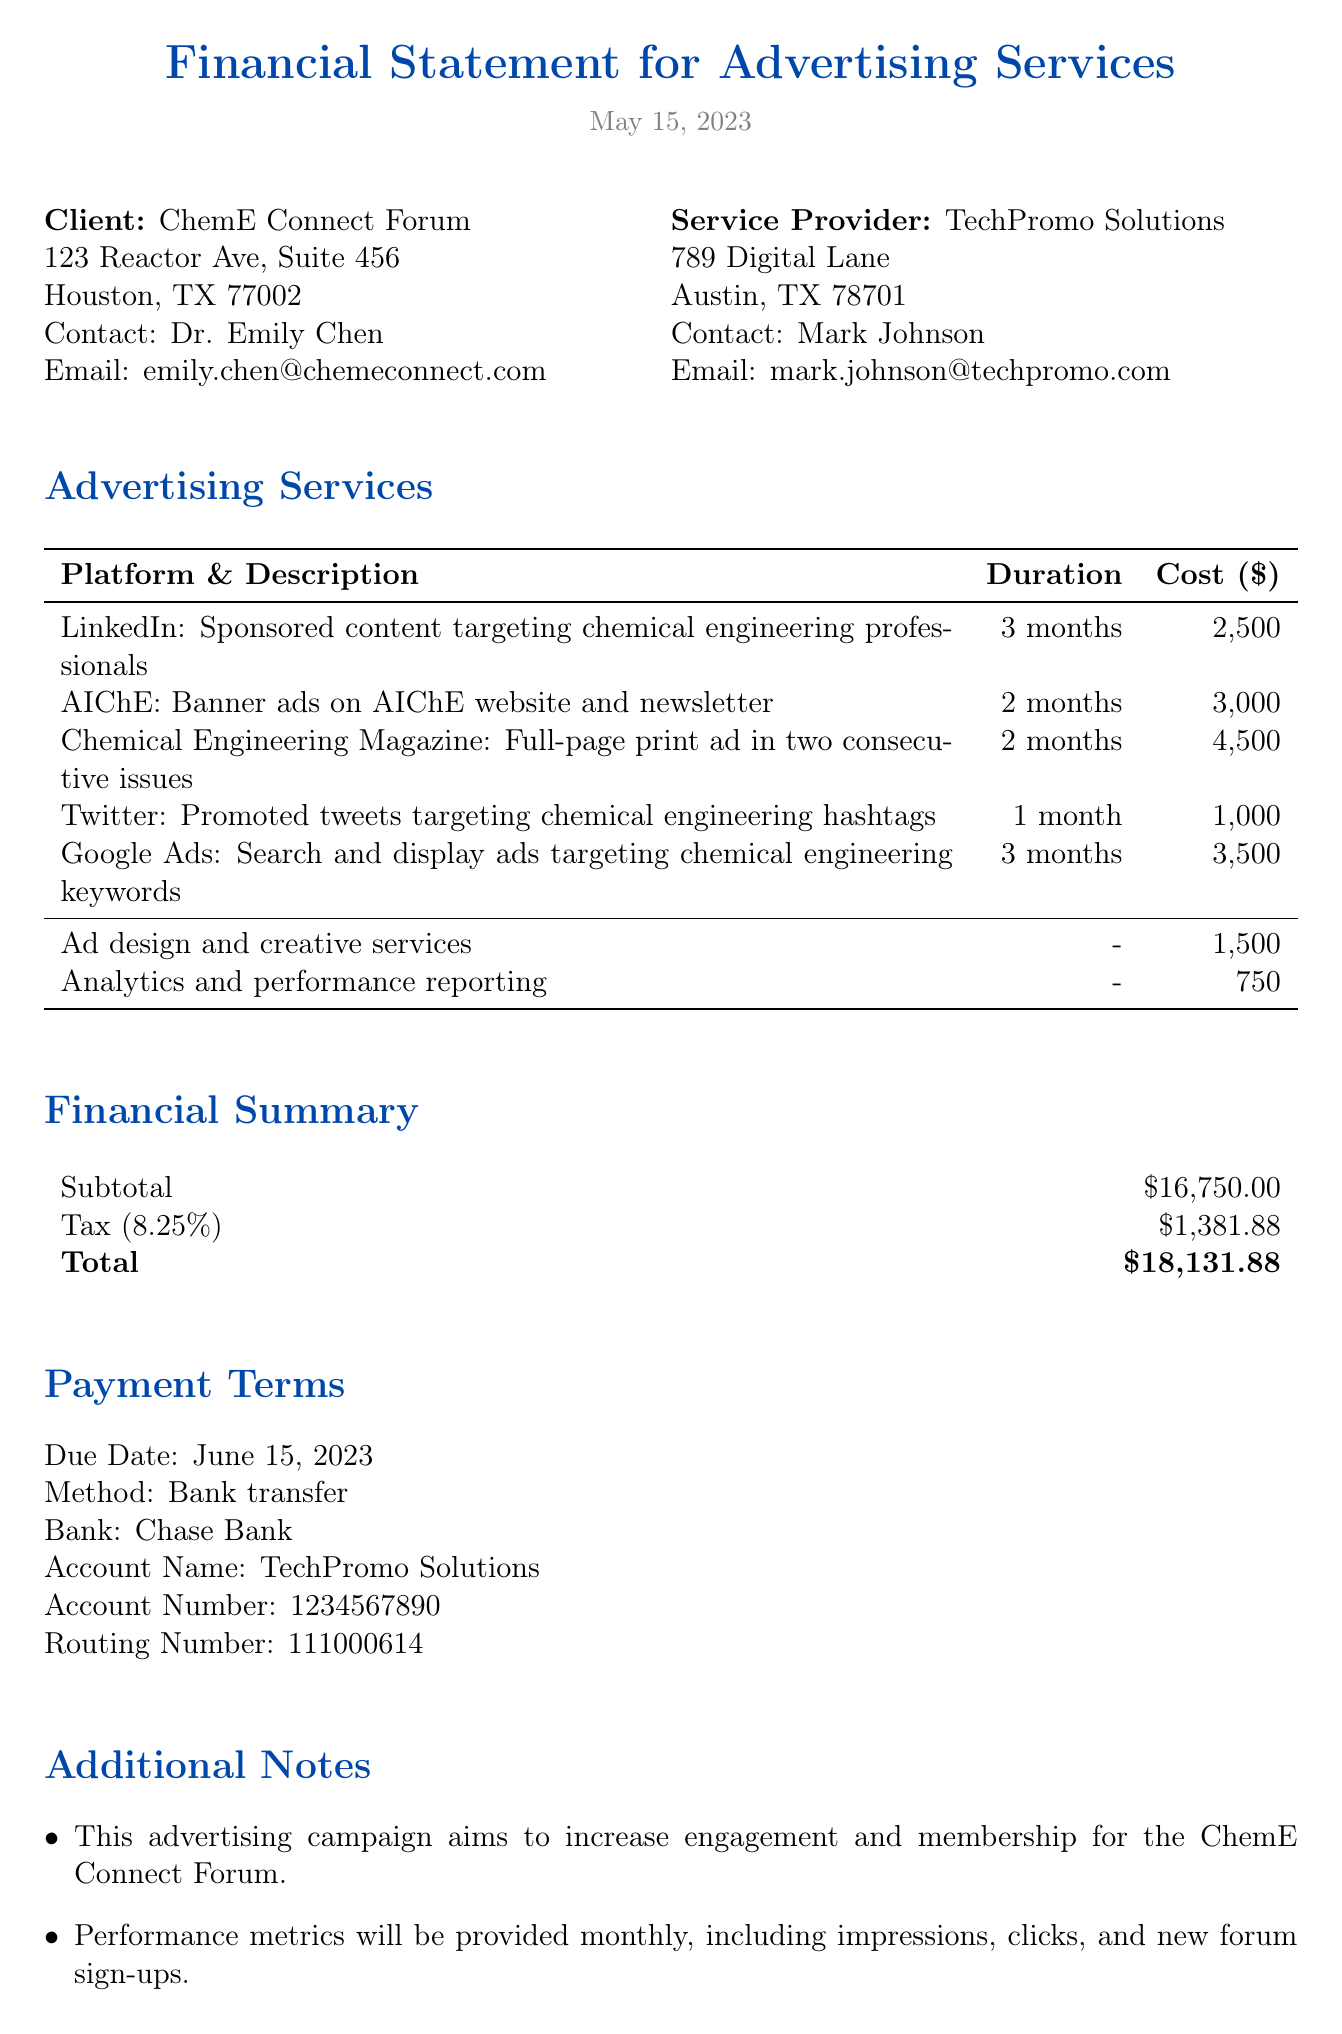what is the title of the document? The title of the document is stated at the beginning, which is "Financial Statement for Advertising Services."
Answer: Financial Statement for Advertising Services who is the contact person for the client? The document provides the name of the client’s contact person, which is "Dr. Emily Chen."
Answer: Dr. Emily Chen what is the subtotal amount listed in the financial summary? The subtotal amount is explicitly stated in the financial summary section of the document, which reads "$16,750."
Answer: 16750 how many months will the LinkedIn advertising run? The duration for the LinkedIn service is mentioned in the advertising services section as "3 months."
Answer: 3 months what additional service is mentioned along with its cost? The document mentions additional services with costs, for example, "Ad design and creative services" for "$1,500."
Answer: Ad design and creative services, $1500 how much is the tax amount charged? The tax amount charged is specifically stated in the financial summary, which is "$1,381.88."
Answer: 1381.88 what is the total cost after tax? The total cost after tax is calculated and presented in the financial summary, shown as "$18,131.88."
Answer: 18131.88 when is the payment due? The payment due date is provided, which is "June 15, 2023."
Answer: June 15, 2023 what platform is not used for advertising in this document? The question requires knowledge of platforms mentioned; the document contains specific platforms for advertising, for example, "Facebook" is not listed.
Answer: Facebook 